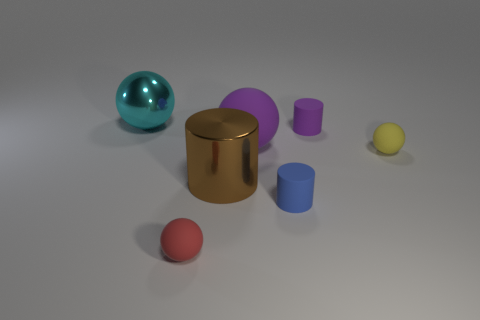What color is the tiny rubber ball to the right of the red rubber sphere?
Make the answer very short. Yellow. What number of other objects are the same color as the large cylinder?
Provide a short and direct response. 0. Is there anything else that has the same size as the purple matte cylinder?
Offer a very short reply. Yes. Is the size of the shiny thing that is to the right of the red rubber thing the same as the tiny yellow matte ball?
Your response must be concise. No. What is the material of the small ball that is behind the brown metallic thing?
Give a very brief answer. Rubber. Is there anything else that is the same shape as the tiny purple rubber thing?
Make the answer very short. Yes. How many rubber objects are small blue cylinders or small yellow objects?
Give a very brief answer. 2. Is the number of large purple objects that are left of the big rubber ball less than the number of brown shiny cubes?
Your response must be concise. No. What is the shape of the thing that is to the left of the rubber ball in front of the shiny thing in front of the large purple sphere?
Keep it short and to the point. Sphere. Do the big matte thing and the large metal cylinder have the same color?
Offer a terse response. No. 